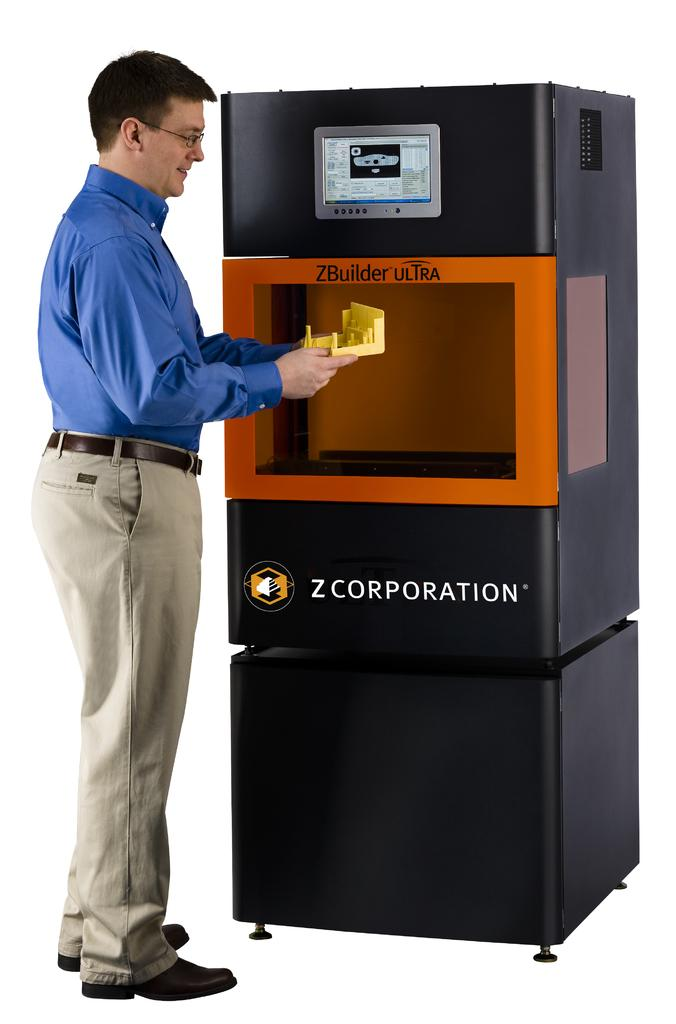Provide a one-sentence caption for the provided image. Man with a blue shirt is standing in front of a ZBuilder Ultra. 